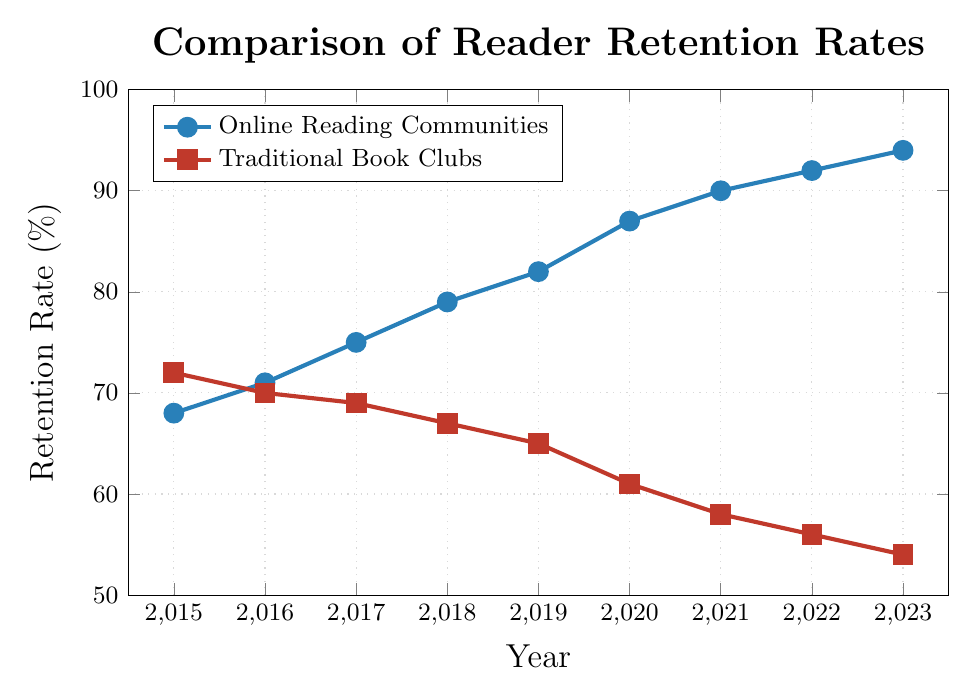How did the retention rate of Traditional Book Clubs change from 2015 to 2023? Look at the retention rate of Traditional Book Clubs in 2015 (72%) and in 2023 (54%), then subtract the latter from the former: 72% - 54% = 18%.
Answer: Decreased by 18% In which year did the retention rate of Online Reading Communities surpass 80%? Observe the data points for Online Reading Communities, you'll see that in 2019 the retention rate first surpasses 80% with a value of 82%.
Answer: 2019 Comparing Online Reading Communities and Traditional Book Clubs, which had a higher retention rate in 2018? Look at 2018 data points: Online Reading Communities had a retention rate of 79% and Traditional Book Clubs had a rate of 67%.
Answer: Online Reading Communities What is the difference in retention rates between Online Reading Communities and Traditional Book Clubs in 2023? The retention rate for Online Reading Communities in 2023 is 94%, and for Traditional Book Clubs, it is 54%. Subtract the latter from the former: 94% - 54% = 40%.
Answer: 40% By how many percentage points did the retention rate for Online Reading Communities increase from 2015 to 2023? Take the retention rates for Online Reading Communities in 2015 (68%) and 2023 (94%) and subtract the former from the latter: 94% - 68% = 26%.
Answer: 26% What color represents the line for Traditional Book Clubs? Visually inspect the color of the line for Traditional Book Clubs on the chart; it is indicated by a color that is typically recognized as red.
Answer: Red By how many percentage points did the retention rate for Traditional Book Clubs drop from 2017 to 2023? Observe the retention rates in 2017 (69%) and 2023 (54%) for Traditional Book Clubs and subtract the latter from the former: 69% - 54% = 15%.
Answer: 15% What was the average retention rate for Online Reading Communities between 2019 and 2023? Take the retention rates for Online Reading Communities from 2019 (82%), 2020 (87%), 2021 (90%), 2022 (92%), and 2023 (94%), sum them up: 82 + 87 + 90 + 92 + 94 = 445. Divide by the number of years, which is 5: 445 / 5 = 89%.
Answer: 89% Which group has the highest retention rate in 2021, and what is the percentage? Compare the 2021 retention rates: Online Reading Communities have 90%, and Traditional Book Clubs have 58%. Therefore, Online Reading Communities have the higher retention rate.
Answer: Online Reading Communities, 90% From 2015 to 2023, which group had the smallest decrease in retention rate? Compare retention rate changes for both groups: Traditional Book Clubs went from 72% to 54% (a decrease of 18%), while Online Reading Communities increased from 68% to 94% (not a decrease but an increase). So, Traditional Book Clubs had a decrease of 18%.
Answer: Traditional Book Clubs 